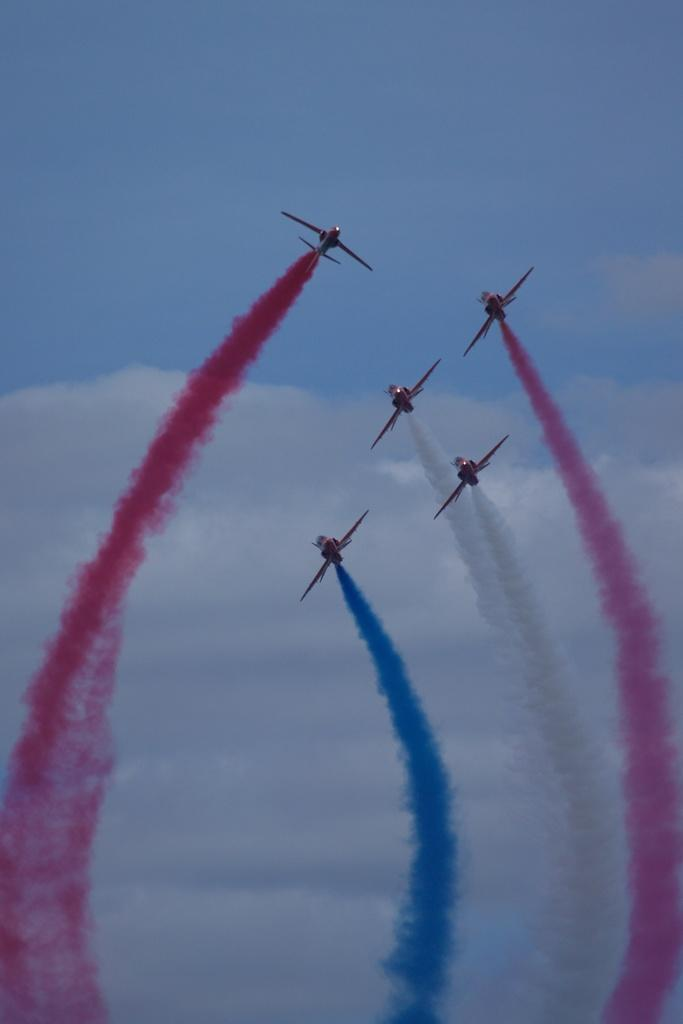What is happening in the sky in the image? There are aircrafts in the air, and smoke is visible in the image. What is the condition of the sky in the background? The sky is cloudy in the background. What type of science is being taught in the image? There is no indication of any teaching or science in the image; it features aircrafts in the air and smoke. What star can be seen shining brightly in the image? There are no stars visible in the image; it focuses on aircrafts, smoke, and the cloudy sky. 